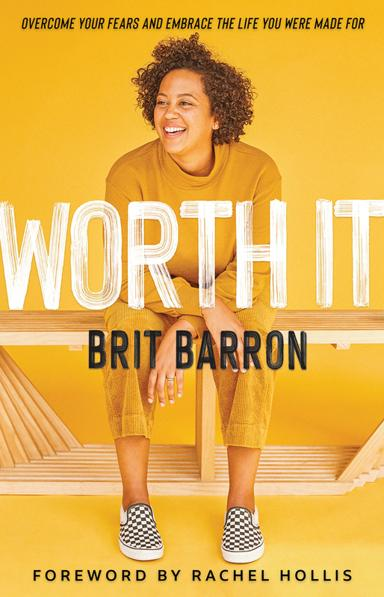What kind of audience is likely the target for this book? The book is ideally targeted towards readers seeking motivation and guidance on personal development. It appeals particularly to those facing personal fears or career stagnation, and it offers actionable advice for embracing change and realizing one's full potential. 